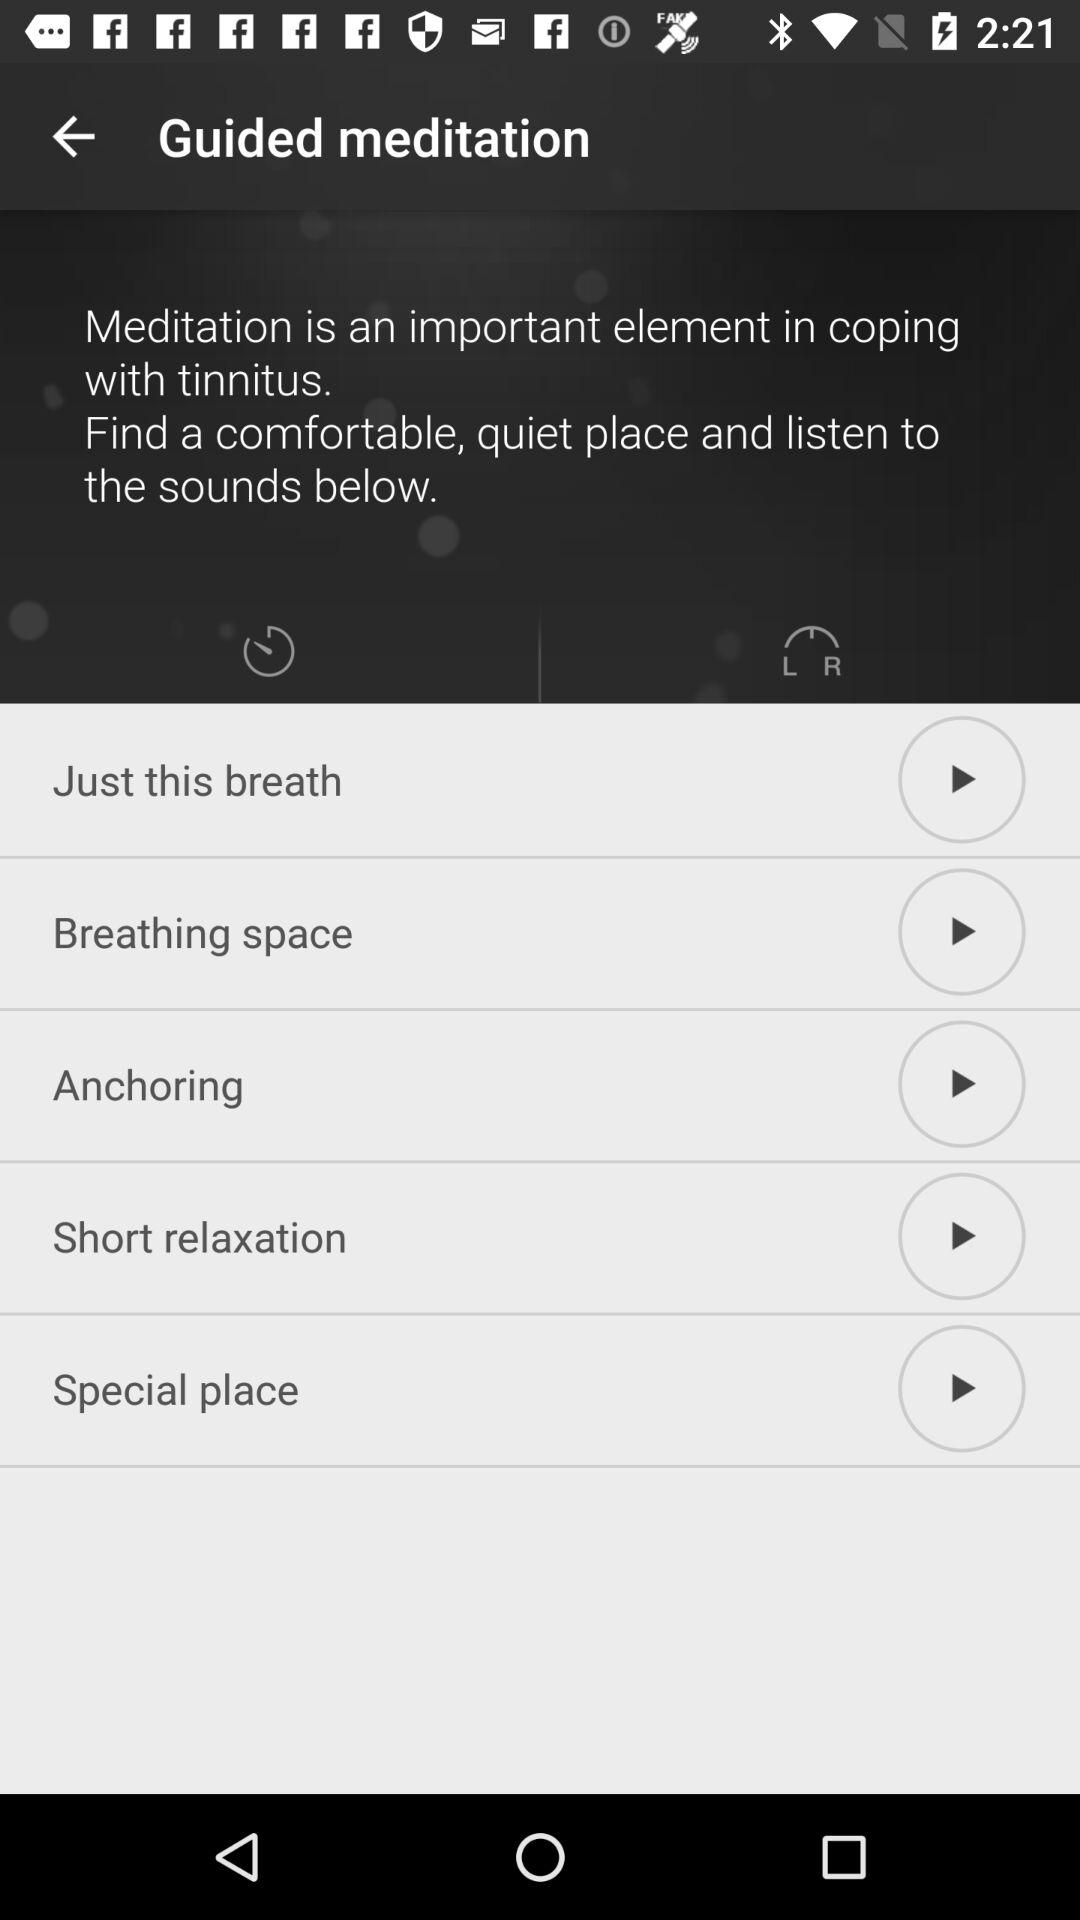How many meditations are there?
Answer the question using a single word or phrase. 5 